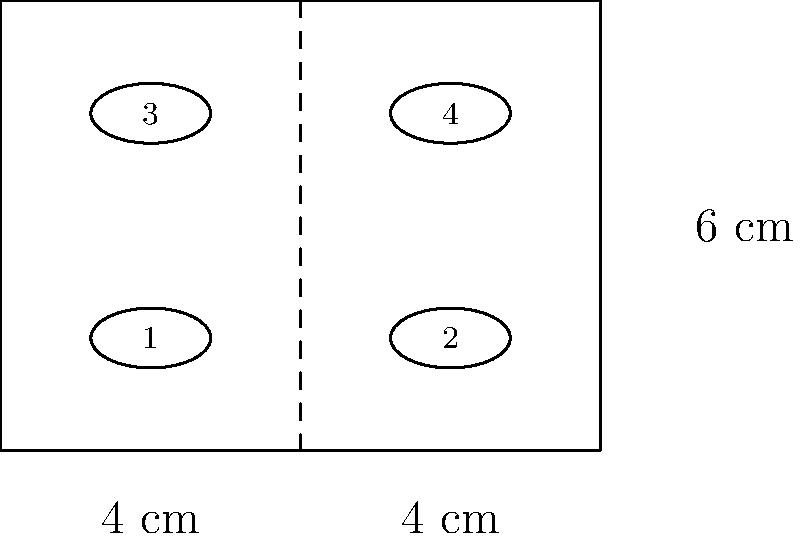Fielmann is offering a special deal on display cases for loyal customers. The rectangular display case measures 8 cm by 6 cm and can fit up to 4 pairs of glasses. Each pair of glasses occupies a circular space with a diameter of 4 cm. What is the maximum number of display cases needed to showcase 100 pairs of glasses while minimizing costs? To solve this problem, we need to follow these steps:

1. Determine how many pairs of glasses fit in one display case:
   The diagram shows that 4 pairs of glasses fit in one case.

2. Calculate how many display cases are needed for 100 pairs of glasses:
   $$ \text{Number of cases} = \frac{\text{Total pairs of glasses}}{\text{Pairs per case}} $$
   $$ \text{Number of cases} = \frac{100}{4} = 25 $$

3. Since we can't have a fractional number of display cases, we need to round up to the nearest whole number to ensure all glasses are displayed.

4. Rounding up 25 to the nearest whole number gives us 25, as it's already a whole number.

Therefore, Fielmann would need a maximum of 25 display cases to showcase 100 pairs of glasses while minimizing costs.
Answer: 25 display cases 